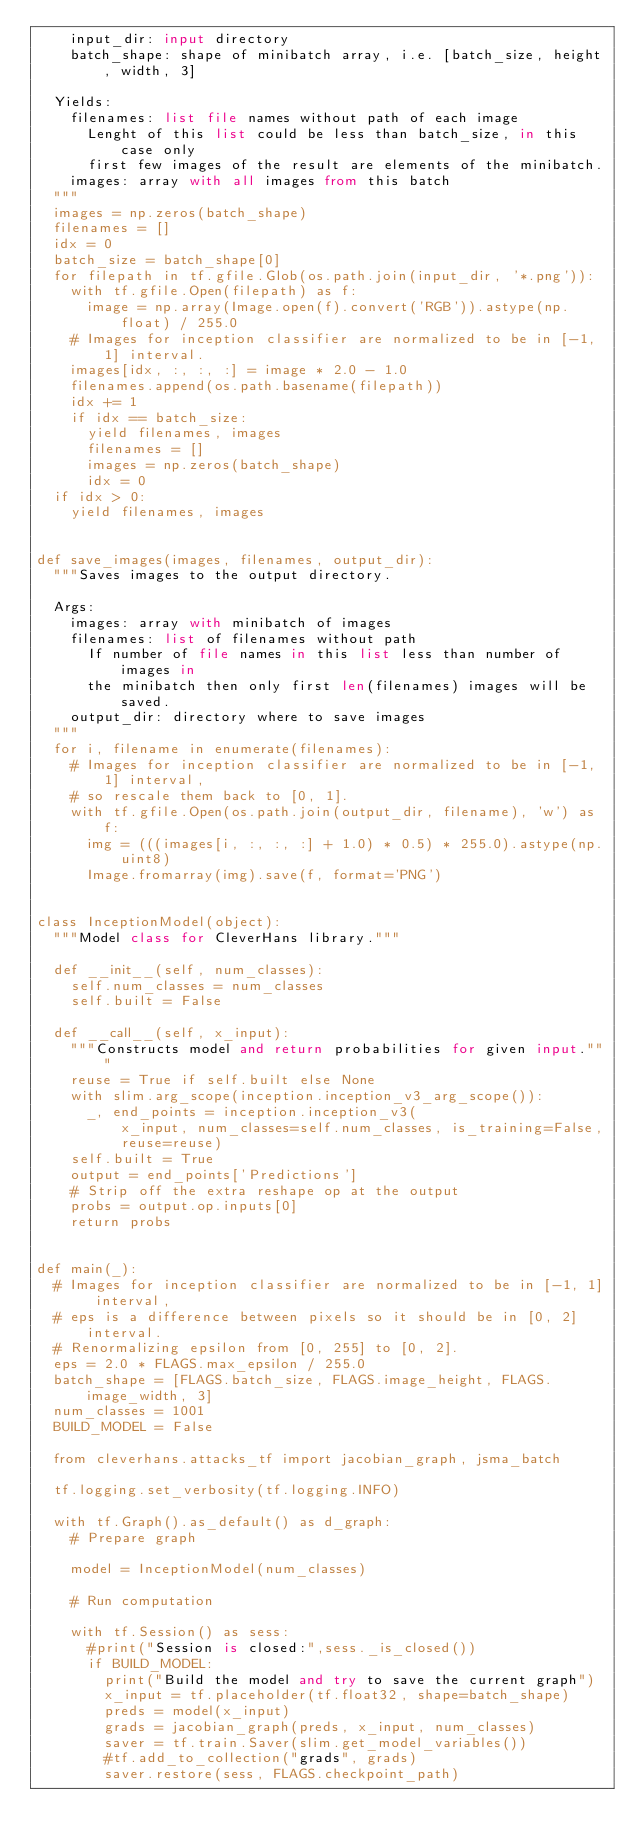Convert code to text. <code><loc_0><loc_0><loc_500><loc_500><_Python_>    input_dir: input directory
    batch_shape: shape of minibatch array, i.e. [batch_size, height, width, 3]

  Yields:
    filenames: list file names without path of each image
      Lenght of this list could be less than batch_size, in this case only
      first few images of the result are elements of the minibatch.
    images: array with all images from this batch
  """
  images = np.zeros(batch_shape)
  filenames = []
  idx = 0
  batch_size = batch_shape[0]
  for filepath in tf.gfile.Glob(os.path.join(input_dir, '*.png')):
    with tf.gfile.Open(filepath) as f:
      image = np.array(Image.open(f).convert('RGB')).astype(np.float) / 255.0
    # Images for inception classifier are normalized to be in [-1, 1] interval.
    images[idx, :, :, :] = image * 2.0 - 1.0
    filenames.append(os.path.basename(filepath))
    idx += 1
    if idx == batch_size:
      yield filenames, images
      filenames = []
      images = np.zeros(batch_shape)
      idx = 0
  if idx > 0:
    yield filenames, images


def save_images(images, filenames, output_dir):
  """Saves images to the output directory.

  Args:
    images: array with minibatch of images
    filenames: list of filenames without path
      If number of file names in this list less than number of images in
      the minibatch then only first len(filenames) images will be saved.
    output_dir: directory where to save images
  """
  for i, filename in enumerate(filenames):
    # Images for inception classifier are normalized to be in [-1, 1] interval,
    # so rescale them back to [0, 1].
    with tf.gfile.Open(os.path.join(output_dir, filename), 'w') as f:
      img = (((images[i, :, :, :] + 1.0) * 0.5) * 255.0).astype(np.uint8)
      Image.fromarray(img).save(f, format='PNG')


class InceptionModel(object):
  """Model class for CleverHans library."""

  def __init__(self, num_classes):
    self.num_classes = num_classes
    self.built = False

  def __call__(self, x_input):
    """Constructs model and return probabilities for given input."""
    reuse = True if self.built else None
    with slim.arg_scope(inception.inception_v3_arg_scope()):
      _, end_points = inception.inception_v3(
          x_input, num_classes=self.num_classes, is_training=False,
          reuse=reuse)
    self.built = True
    output = end_points['Predictions']
    # Strip off the extra reshape op at the output
    probs = output.op.inputs[0]
    return probs


def main(_):
  # Images for inception classifier are normalized to be in [-1, 1] interval,
  # eps is a difference between pixels so it should be in [0, 2] interval.
  # Renormalizing epsilon from [0, 255] to [0, 2].
  eps = 2.0 * FLAGS.max_epsilon / 255.0
  batch_shape = [FLAGS.batch_size, FLAGS.image_height, FLAGS.image_width, 3]
  num_classes = 1001
  BUILD_MODEL = False

  from cleverhans.attacks_tf import jacobian_graph, jsma_batch

  tf.logging.set_verbosity(tf.logging.INFO)

  with tf.Graph().as_default() as d_graph:
    # Prepare graph

    model = InceptionModel(num_classes)

    # Run computation

    with tf.Session() as sess:
      #print("Session is closed:",sess._is_closed())
      if BUILD_MODEL:
        print("Build the model and try to save the current graph")
        x_input = tf.placeholder(tf.float32, shape=batch_shape)
        preds = model(x_input)
        grads = jacobian_graph(preds, x_input, num_classes)
        saver = tf.train.Saver(slim.get_model_variables())
        #tf.add_to_collection("grads", grads)
        saver.restore(sess, FLAGS.checkpoint_path)</code> 